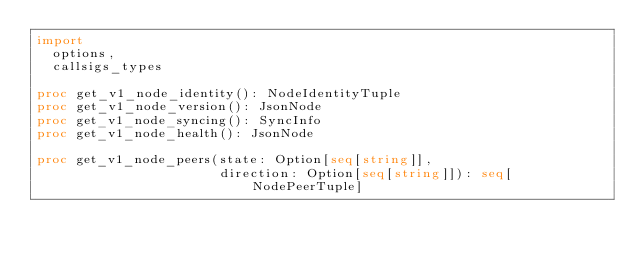Convert code to text. <code><loc_0><loc_0><loc_500><loc_500><_Nim_>import
  options,
  callsigs_types

proc get_v1_node_identity(): NodeIdentityTuple
proc get_v1_node_version(): JsonNode
proc get_v1_node_syncing(): SyncInfo
proc get_v1_node_health(): JsonNode

proc get_v1_node_peers(state: Option[seq[string]],
                       direction: Option[seq[string]]): seq[NodePeerTuple]
</code> 